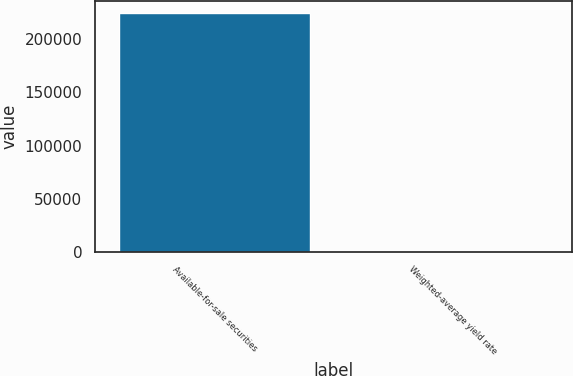Convert chart to OTSL. <chart><loc_0><loc_0><loc_500><loc_500><bar_chart><fcel>Available-for-sale securities<fcel>Weighted-average yield rate<nl><fcel>225009<fcel>0.91<nl></chart> 